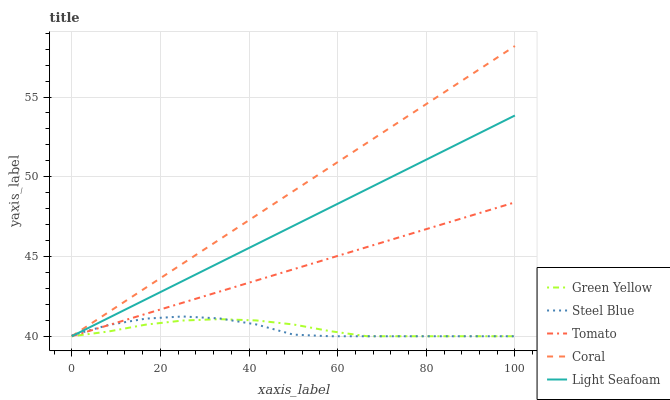Does Green Yellow have the minimum area under the curve?
Answer yes or no. No. Does Green Yellow have the maximum area under the curve?
Answer yes or no. No. Is Coral the smoothest?
Answer yes or no. No. Is Coral the roughest?
Answer yes or no. No. Does Green Yellow have the highest value?
Answer yes or no. No. 